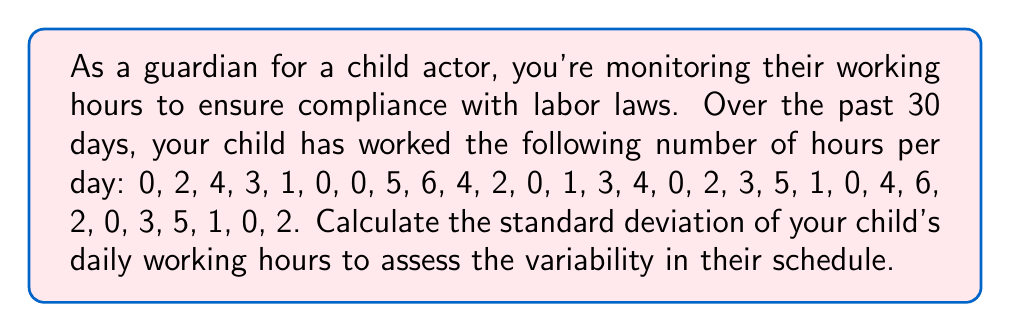Teach me how to tackle this problem. To calculate the standard deviation, we'll follow these steps:

1. Calculate the mean (average) of the working hours:
   $\bar{x} = \frac{\sum_{i=1}^{n} x_i}{n} = \frac{69}{30} = 2.3$ hours

2. Calculate the squared differences from the mean:
   $(0-2.3)^2, (2-2.3)^2, (4-2.3)^2, ..., (2-2.3)^2$

3. Sum the squared differences:
   $\sum_{i=1}^{n} (x_i - \bar{x})^2 = 185.1$

4. Divide by $(n-1)$ to get the variance:
   $s^2 = \frac{\sum_{i=1}^{n} (x_i - \bar{x})^2}{n-1} = \frac{185.1}{29} = 6.3827586$

5. Take the square root to get the standard deviation:
   $s = \sqrt{6.3827586} = 2.5264$ hours

The standard deviation is approximately 2.5264 hours.
Answer: $2.5264$ hours 